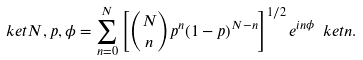Convert formula to latex. <formula><loc_0><loc_0><loc_500><loc_500>\ k e t { N , p , \phi } = \sum _ { n = 0 } ^ { N } \left [ { N \choose n } p ^ { n } ( 1 - p ) ^ { N - n } \right ] ^ { 1 / 2 } e ^ { i n \phi } \ k e t { n } .</formula> 